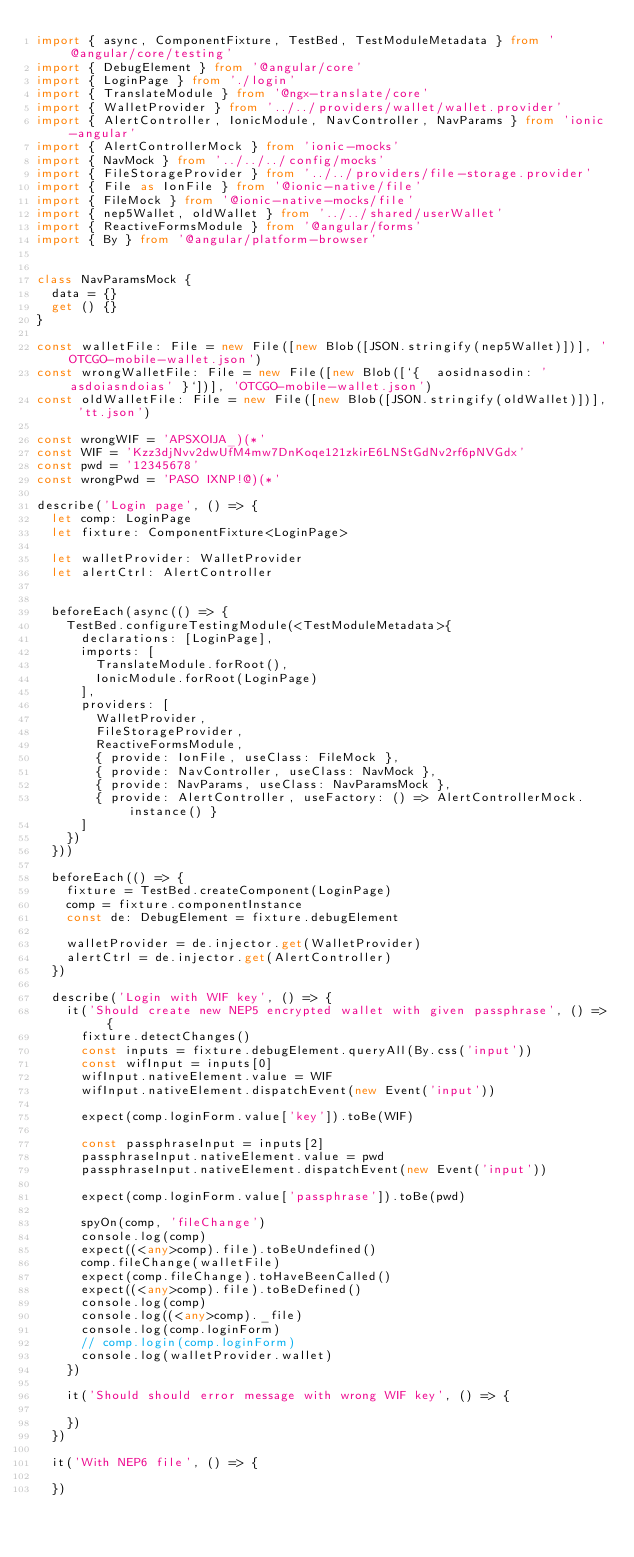Convert code to text. <code><loc_0><loc_0><loc_500><loc_500><_TypeScript_>import { async, ComponentFixture, TestBed, TestModuleMetadata } from '@angular/core/testing'
import { DebugElement } from '@angular/core'
import { LoginPage } from './login'
import { TranslateModule } from '@ngx-translate/core'
import { WalletProvider } from '../../providers/wallet/wallet.provider'
import { AlertController, IonicModule, NavController, NavParams } from 'ionic-angular'
import { AlertControllerMock } from 'ionic-mocks'
import { NavMock } from '../../../config/mocks'
import { FileStorageProvider } from '../../providers/file-storage.provider'
import { File as IonFile } from '@ionic-native/file'
import { FileMock } from '@ionic-native-mocks/file'
import { nep5Wallet, oldWallet } from '../../shared/userWallet'
import { ReactiveFormsModule } from '@angular/forms'
import { By } from '@angular/platform-browser'


class NavParamsMock {
	data = {}
	get () {}
}

const walletFile: File = new File([new Blob([JSON.stringify(nep5Wallet)])], 'OTCGO-mobile-wallet.json')
const wrongWalletFile: File = new File([new Blob([`{  aosidnasodin: 'asdoiasndoias' }`])], 'OTCGO-mobile-wallet.json')
const oldWalletFile: File = new File([new Blob([JSON.stringify(oldWallet)])], 'tt.json')

const wrongWIF = 'APSXOIJA_)(*'
const WIF = 'Kzz3djNvv2dwUfM4mw7DnKoqe121zkirE6LNStGdNv2rf6pNVGdx'
const pwd = '12345678'
const wrongPwd = 'PASO IXNP!@)(*'

describe('Login page', () => {
	let comp: LoginPage
	let fixture: ComponentFixture<LoginPage>

	let walletProvider: WalletProvider
	let alertCtrl: AlertController


	beforeEach(async(() => {
		TestBed.configureTestingModule(<TestModuleMetadata>{
			declarations: [LoginPage],
			imports: [
				TranslateModule.forRoot(),
				IonicModule.forRoot(LoginPage)
			],
			providers: [
				WalletProvider,
				FileStorageProvider,
				ReactiveFormsModule,
				{ provide: IonFile, useClass: FileMock },
				{ provide: NavController, useClass: NavMock },
				{ provide: NavParams, useClass: NavParamsMock },
				{ provide: AlertController, useFactory: () => AlertControllerMock.instance() }
			]
		})
	}))

	beforeEach(() => {
		fixture = TestBed.createComponent(LoginPage)
		comp = fixture.componentInstance
		const de: DebugElement = fixture.debugElement

		walletProvider = de.injector.get(WalletProvider)
		alertCtrl = de.injector.get(AlertController)
	})

	describe('Login with WIF key', () => {
		it('Should create new NEP5 encrypted wallet with given passphrase', () => {
			fixture.detectChanges()
			const inputs = fixture.debugElement.queryAll(By.css('input'))
			const wifInput = inputs[0]
			wifInput.nativeElement.value = WIF
			wifInput.nativeElement.dispatchEvent(new Event('input'))

			expect(comp.loginForm.value['key']).toBe(WIF)

			const passphraseInput = inputs[2]
			passphraseInput.nativeElement.value = pwd
			passphraseInput.nativeElement.dispatchEvent(new Event('input'))

			expect(comp.loginForm.value['passphrase']).toBe(pwd)

			spyOn(comp, 'fileChange')
			console.log(comp)
			expect((<any>comp).file).toBeUndefined()
			comp.fileChange(walletFile)
			expect(comp.fileChange).toHaveBeenCalled()
			expect((<any>comp).file).toBeDefined()
			console.log(comp)
			console.log((<any>comp)._file)
			console.log(comp.loginForm)
			// comp.login(comp.loginForm)
			console.log(walletProvider.wallet)
		})

		it('Should should error message with wrong WIF key', () => {

		})
	})

	it('With NEP6 file', () => {

	})
</code> 